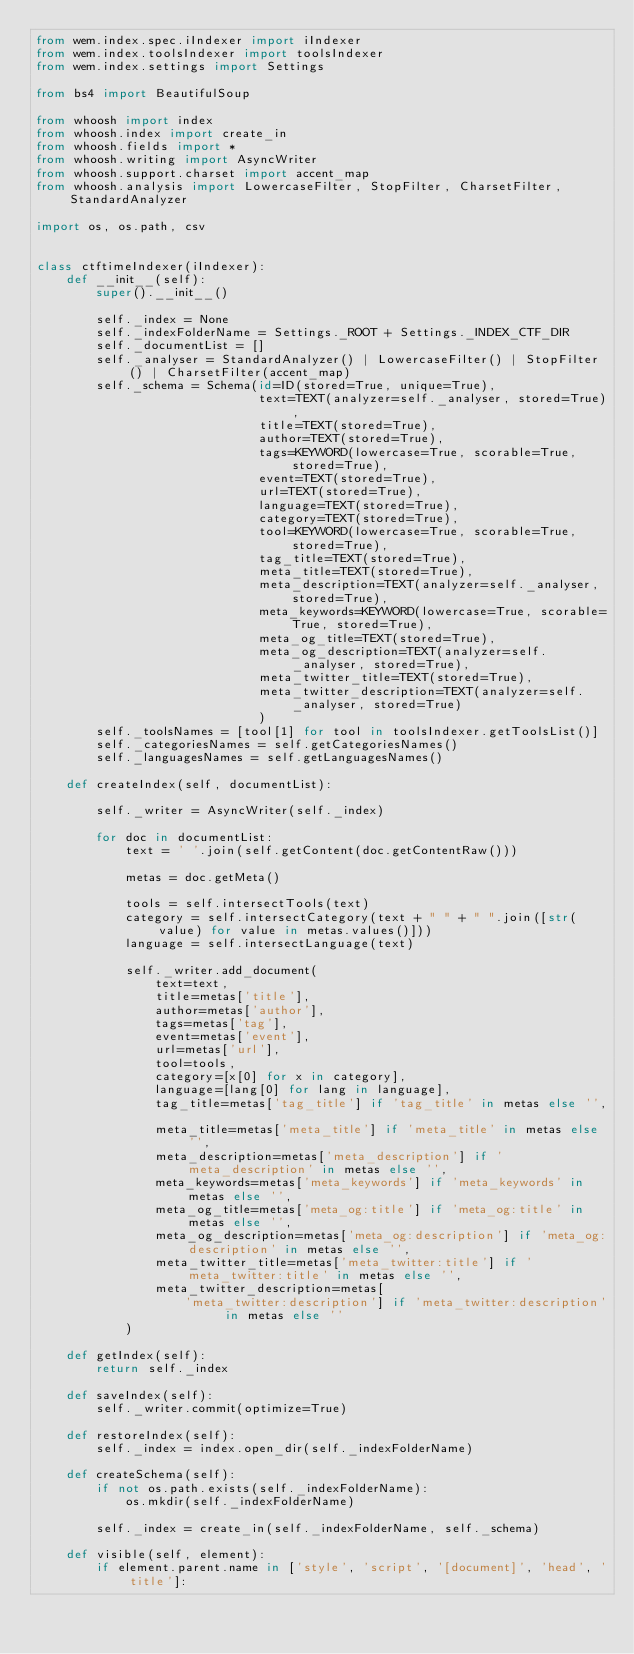Convert code to text. <code><loc_0><loc_0><loc_500><loc_500><_Python_>from wem.index.spec.iIndexer import iIndexer
from wem.index.toolsIndexer import toolsIndexer
from wem.index.settings import Settings

from bs4 import BeautifulSoup

from whoosh import index
from whoosh.index import create_in
from whoosh.fields import *
from whoosh.writing import AsyncWriter
from whoosh.support.charset import accent_map
from whoosh.analysis import LowercaseFilter, StopFilter, CharsetFilter, StandardAnalyzer

import os, os.path, csv


class ctftimeIndexer(iIndexer):
    def __init__(self):
        super().__init__()

        self._index = None
        self._indexFolderName = Settings._ROOT + Settings._INDEX_CTF_DIR
        self._documentList = []
        self._analyser = StandardAnalyzer() | LowercaseFilter() | StopFilter() | CharsetFilter(accent_map)
        self._schema = Schema(id=ID(stored=True, unique=True),
                              text=TEXT(analyzer=self._analyser, stored=True),
                              title=TEXT(stored=True),
                              author=TEXT(stored=True),
                              tags=KEYWORD(lowercase=True, scorable=True, stored=True),
                              event=TEXT(stored=True),
                              url=TEXT(stored=True),
                              language=TEXT(stored=True),
                              category=TEXT(stored=True),
                              tool=KEYWORD(lowercase=True, scorable=True, stored=True),
                              tag_title=TEXT(stored=True),
                              meta_title=TEXT(stored=True),
                              meta_description=TEXT(analyzer=self._analyser, stored=True),
                              meta_keywords=KEYWORD(lowercase=True, scorable=True, stored=True),
                              meta_og_title=TEXT(stored=True),
                              meta_og_description=TEXT(analyzer=self._analyser, stored=True),
                              meta_twitter_title=TEXT(stored=True),
                              meta_twitter_description=TEXT(analyzer=self._analyser, stored=True)
                              )
        self._toolsNames = [tool[1] for tool in toolsIndexer.getToolsList()]
        self._categoriesNames = self.getCategoriesNames()
        self._languagesNames = self.getLanguagesNames()

    def createIndex(self, documentList):

        self._writer = AsyncWriter(self._index)

        for doc in documentList:
            text = ' '.join(self.getContent(doc.getContentRaw()))

            metas = doc.getMeta()

            tools = self.intersectTools(text)
            category = self.intersectCategory(text + " " + " ".join([str(value) for value in metas.values()]))
            language = self.intersectLanguage(text)

            self._writer.add_document(
                text=text,
                title=metas['title'],
                author=metas['author'],
                tags=metas['tag'],
                event=metas['event'],
                url=metas['url'],
                tool=tools,
                category=[x[0] for x in category],
                language=[lang[0] for lang in language],
                tag_title=metas['tag_title'] if 'tag_title' in metas else '',

                meta_title=metas['meta_title'] if 'meta_title' in metas else '',
                meta_description=metas['meta_description'] if 'meta_description' in metas else '',
                meta_keywords=metas['meta_keywords'] if 'meta_keywords' in metas else '',
                meta_og_title=metas['meta_og:title'] if 'meta_og:title' in metas else '',
                meta_og_description=metas['meta_og:description'] if 'meta_og:description' in metas else '',
                meta_twitter_title=metas['meta_twitter:title'] if 'meta_twitter:title' in metas else '',
                meta_twitter_description=metas[
                    'meta_twitter:description'] if 'meta_twitter:description' in metas else ''
            )

    def getIndex(self):
        return self._index

    def saveIndex(self):
        self._writer.commit(optimize=True)

    def restoreIndex(self):
        self._index = index.open_dir(self._indexFolderName)

    def createSchema(self):
        if not os.path.exists(self._indexFolderName):
            os.mkdir(self._indexFolderName)

        self._index = create_in(self._indexFolderName, self._schema)

    def visible(self, element):
        if element.parent.name in ['style', 'script', '[document]', 'head', 'title']:</code> 